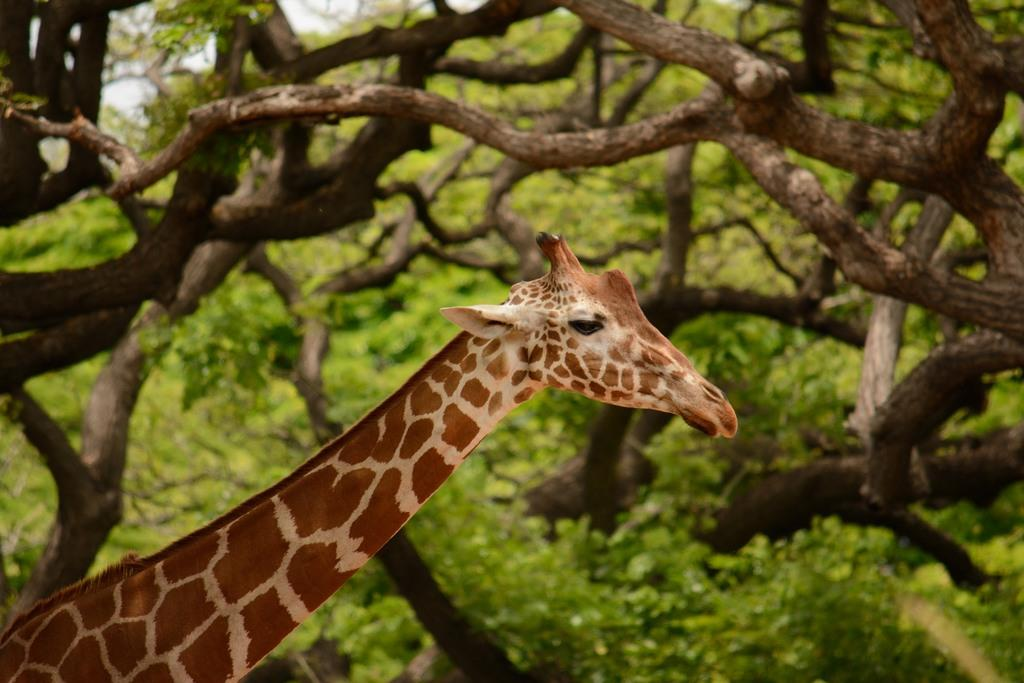What animal is present in the picture? There is a giraffe in the picture. What type of vegetation can be seen in the picture? Branches of a tree are visible in the picture. What type of bells can be heard ringing in the picture? There are no bells present in the picture, and therefore no sounds can be heard. 